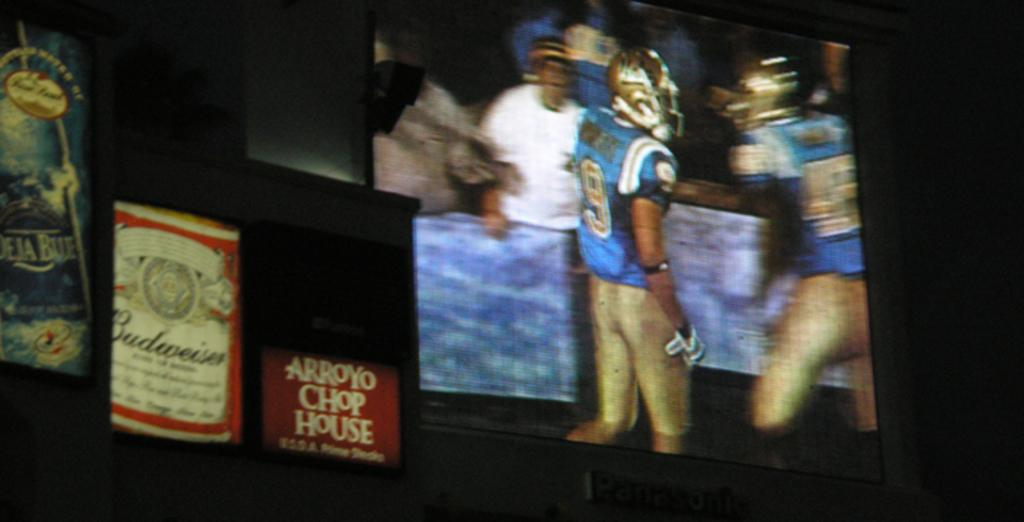What colors are present on the boards in the image? The boards in the image have blue, red, and white colors. What electronic device is visible in the image? There is a television in the image. What can be seen on the television? Few persons are visible on the television. What is in the background of the image? There is a wall in the background of the image. Can you see a bike parked near the wall in the image? There is no bike present in the image. Is there a harbor visible in the background of the image? There is no harbor present in the image; it only shows a wall in the background. 